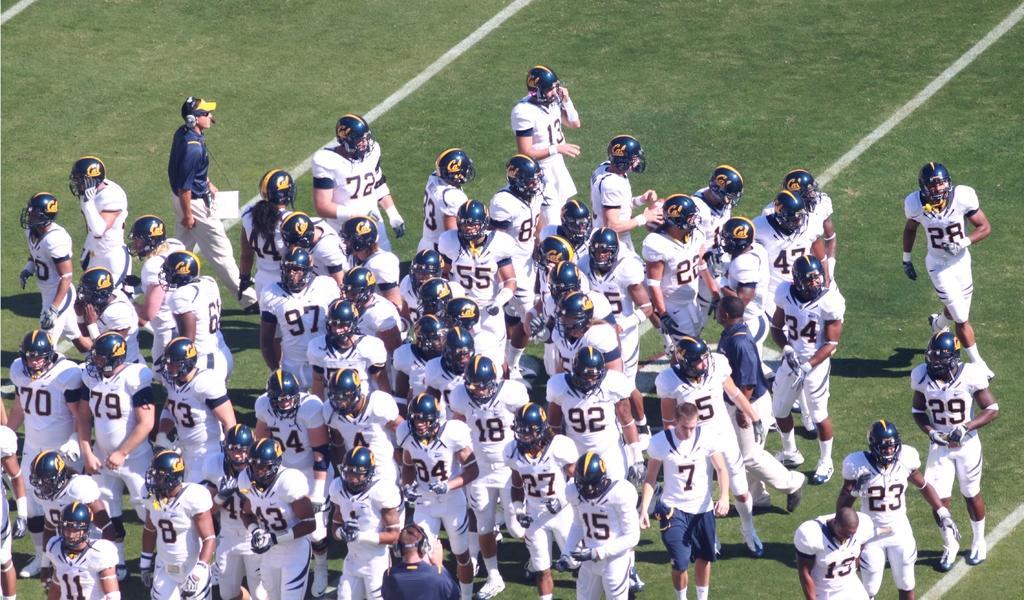Can you describe this image briefly? This picture shows bunch of players. They wore helmets on their heads and they wore white color dress and we see couple of men wore blue color shirts with caps on their heads and they wore headsets and a man carrying papers in his hand and we see a greenfield. 